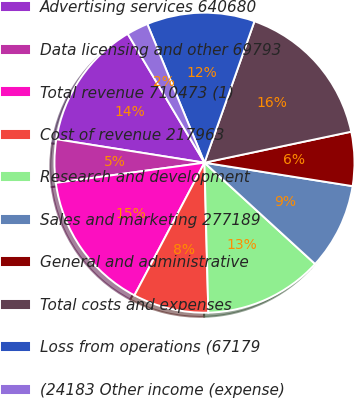<chart> <loc_0><loc_0><loc_500><loc_500><pie_chart><fcel>Advertising services 640680<fcel>Data licensing and other 69793<fcel>Total revenue 710473 (1)<fcel>Cost of revenue 217963<fcel>Research and development<fcel>Sales and marketing 277189<fcel>General and administrative<fcel>Total costs and expenses<fcel>Loss from operations (67179<fcel>(24183 Other income (expense)<nl><fcel>13.95%<fcel>4.65%<fcel>15.12%<fcel>8.14%<fcel>12.79%<fcel>9.3%<fcel>5.81%<fcel>16.28%<fcel>11.63%<fcel>2.33%<nl></chart> 